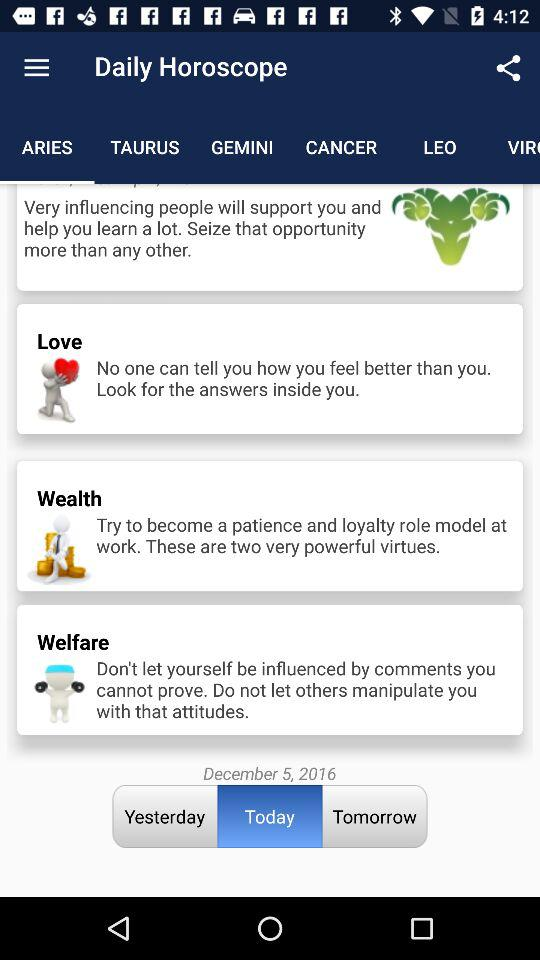Which tab has selected? The tab that has been selected is "ARIES". 